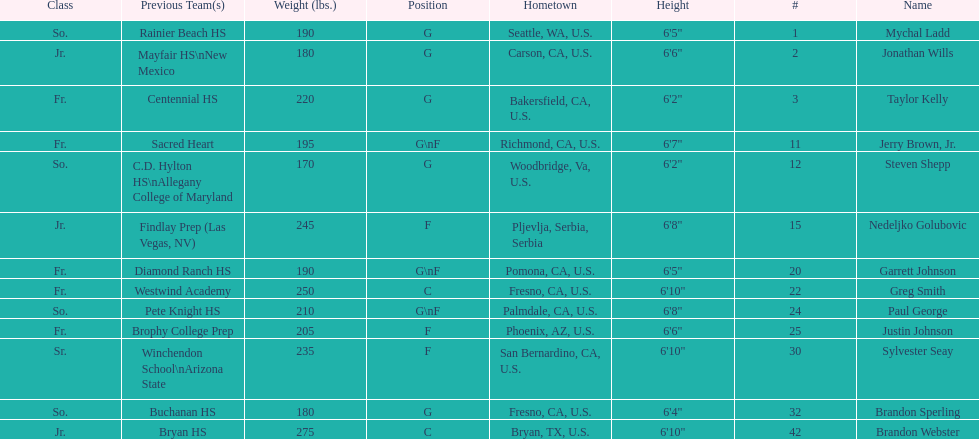Who is the next heaviest player after nedelijko golubovic? Sylvester Seay. 